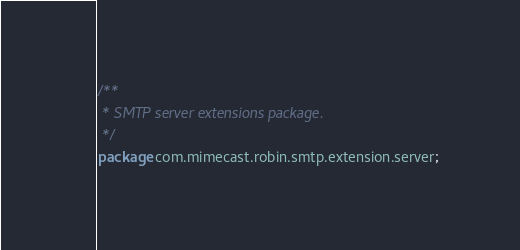Convert code to text. <code><loc_0><loc_0><loc_500><loc_500><_Java_>/**
 * SMTP server extensions package.
 */
package com.mimecast.robin.smtp.extension.server;
</code> 